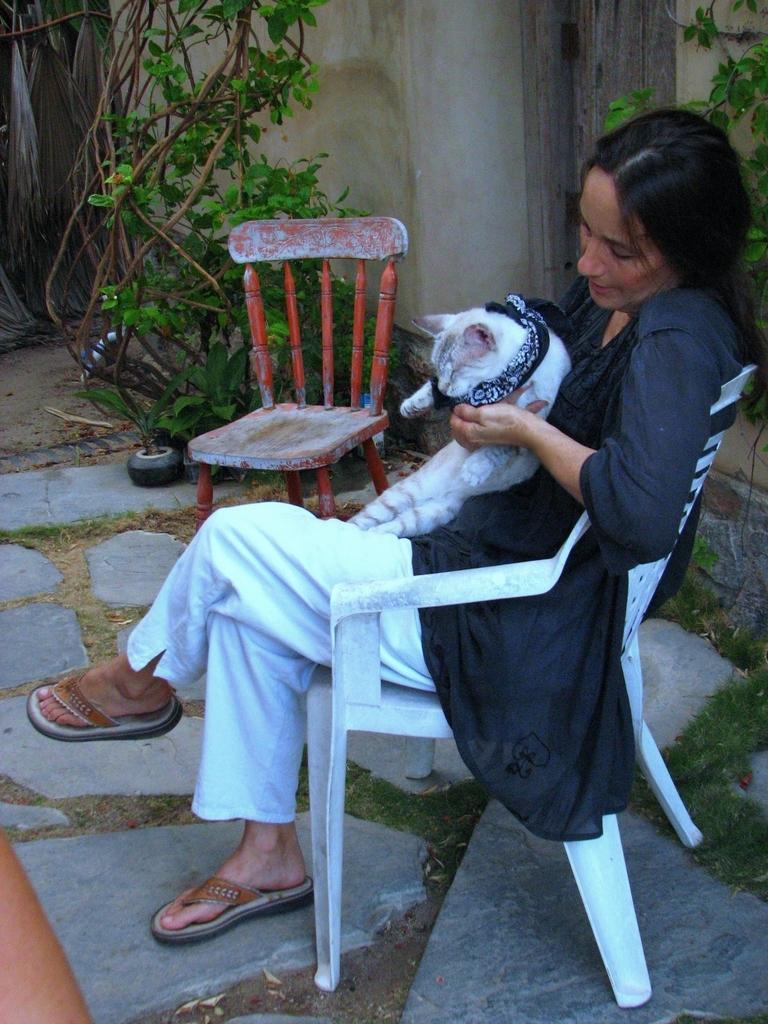Please provide a concise description of this image. A woman is sitting in chair holding a cat in her hand. There another chair beside her. There is a plant in the background. 